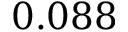<formula> <loc_0><loc_0><loc_500><loc_500>0 . 0 8 8</formula> 